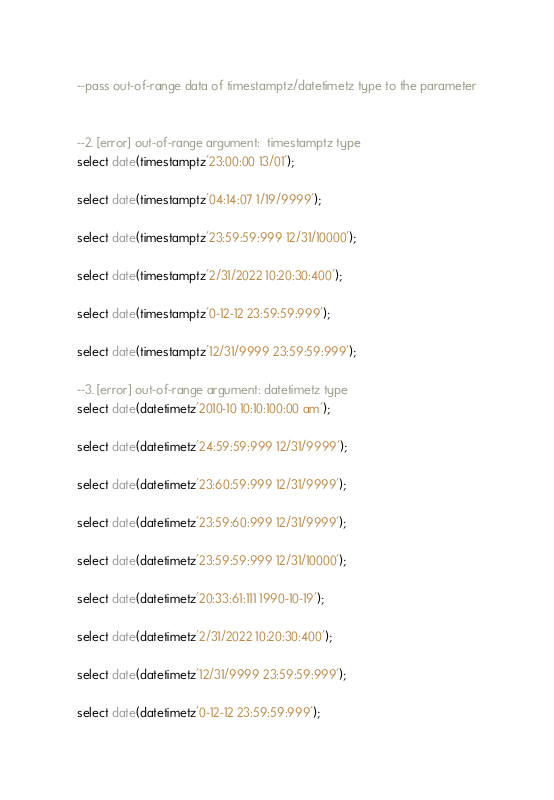Convert code to text. <code><loc_0><loc_0><loc_500><loc_500><_SQL_>--pass out-of-range data of timestamptz/datetimetz type to the parameter


--2. [error] out-of-range argument:  timestamptz type
select date(timestamptz'23:00:00 13/01');

select date(timestamptz'04:14:07 1/19/9999');

select date(timestamptz'23:59:59:999 12/31/10000');

select date(timestamptz'2/31/2022 10:20:30:400');

select date(timestamptz'0-12-12 23:59:59:999');

select date(timestamptz'12/31/9999 23:59:59:999');

--3. [error] out-of-range argument: datetimetz type
select date(datetimetz'2010-10 10:10:100:00 am');

select date(datetimetz'24:59:59:999 12/31/9999');

select date(datetimetz'23:60:59:999 12/31/9999');

select date(datetimetz'23:59:60:999 12/31/9999');

select date(datetimetz'23:59:59:999 12/31/10000');

select date(datetimetz'20:33:61:111 1990-10-19');

select date(datetimetz'2/31/2022 10:20:30:400');

select date(datetimetz'12/31/9999 23:59:59:999');

select date(datetimetz'0-12-12 23:59:59:999');
</code> 